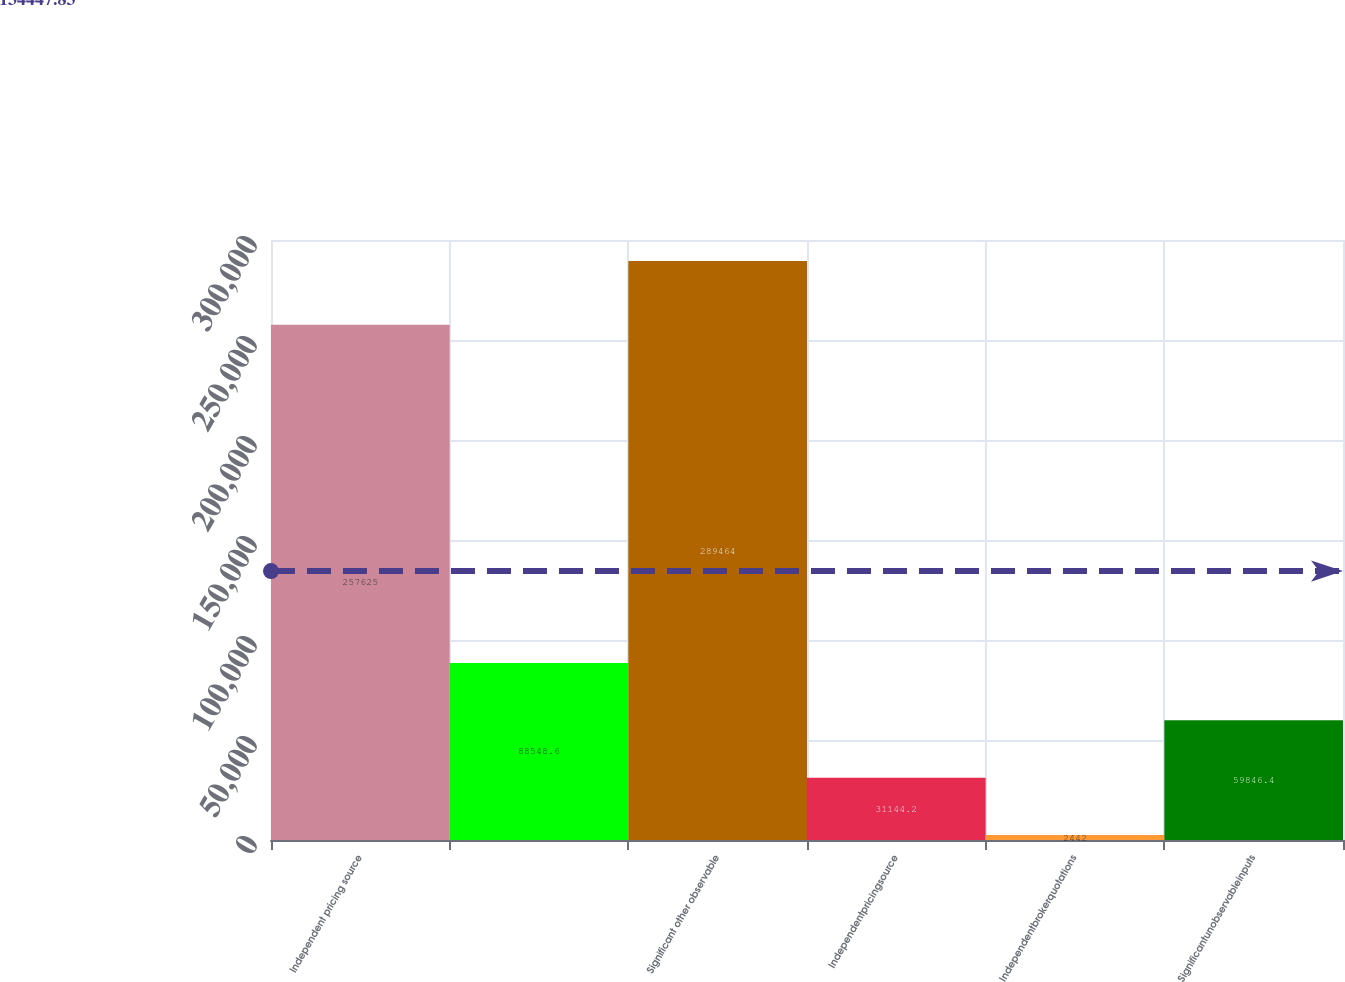Convert chart. <chart><loc_0><loc_0><loc_500><loc_500><bar_chart><fcel>Independent pricing source<fcel>Unnamed: 1<fcel>Significant other observable<fcel>Independentpricingsource<fcel>Independentbrokerquotations<fcel>Significantunobservableinputs<nl><fcel>257625<fcel>88548.6<fcel>289464<fcel>31144.2<fcel>2442<fcel>59846.4<nl></chart> 